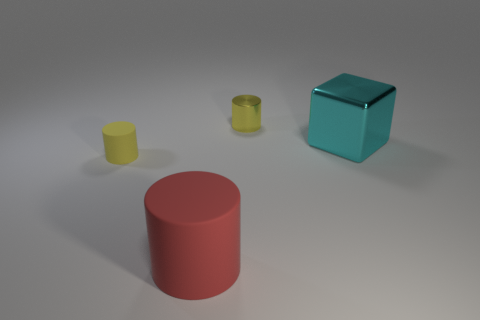Add 2 gray rubber balls. How many objects exist? 6 Subtract all cylinders. How many objects are left? 1 Add 1 small rubber things. How many small rubber things exist? 2 Subtract 0 gray cubes. How many objects are left? 4 Subtract all big purple shiny cylinders. Subtract all large red rubber objects. How many objects are left? 3 Add 4 tiny yellow matte cylinders. How many tiny yellow matte cylinders are left? 5 